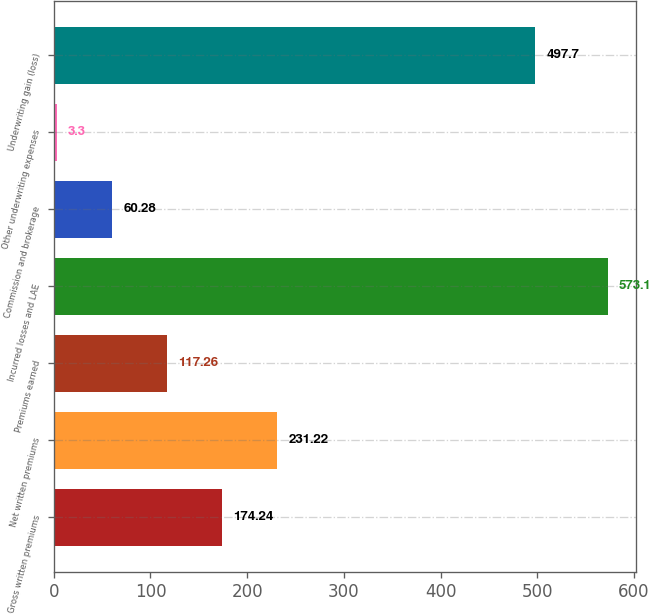Convert chart to OTSL. <chart><loc_0><loc_0><loc_500><loc_500><bar_chart><fcel>Gross written premiums<fcel>Net written premiums<fcel>Premiums earned<fcel>Incurred losses and LAE<fcel>Commission and brokerage<fcel>Other underwriting expenses<fcel>Underwriting gain (loss)<nl><fcel>174.24<fcel>231.22<fcel>117.26<fcel>573.1<fcel>60.28<fcel>3.3<fcel>497.7<nl></chart> 